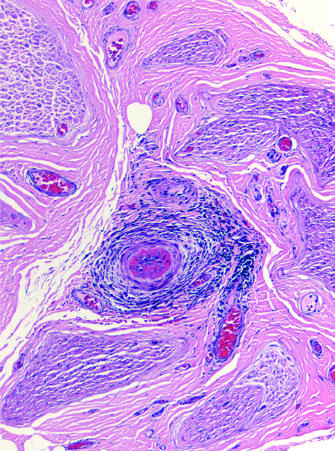does the perineurial connective tissue contain an inflammatory infiltrate around small blood vessels that has obliterated a vessel in b?
Answer the question using a single word or phrase. Yes 